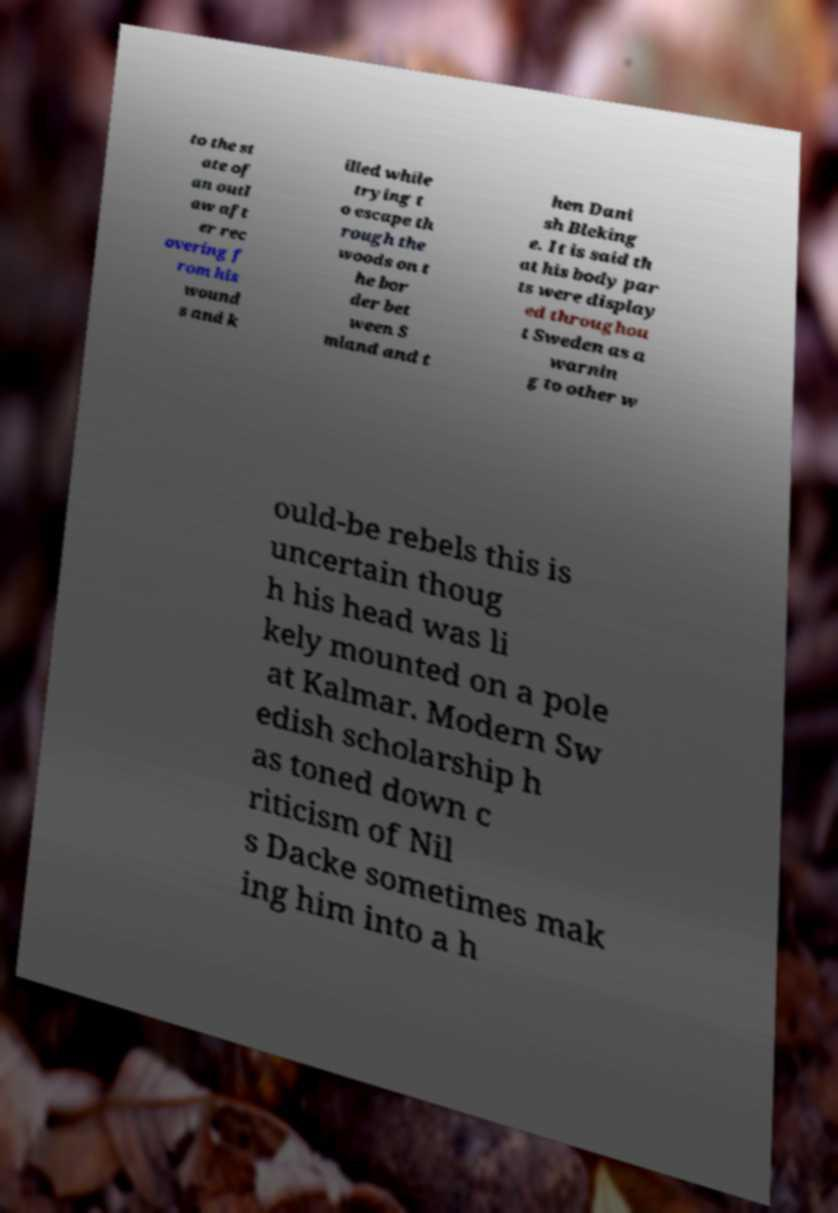Please read and relay the text visible in this image. What does it say? to the st ate of an outl aw aft er rec overing f rom his wound s and k illed while trying t o escape th rough the woods on t he bor der bet ween S mland and t hen Dani sh Bleking e. It is said th at his body par ts were display ed throughou t Sweden as a warnin g to other w ould-be rebels this is uncertain thoug h his head was li kely mounted on a pole at Kalmar. Modern Sw edish scholarship h as toned down c riticism of Nil s Dacke sometimes mak ing him into a h 